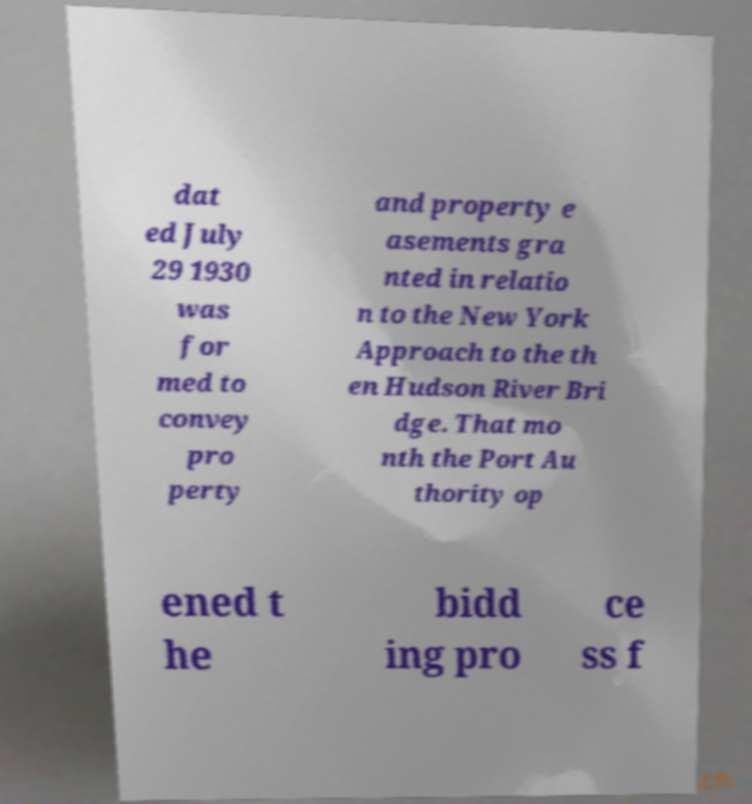For documentation purposes, I need the text within this image transcribed. Could you provide that? dat ed July 29 1930 was for med to convey pro perty and property e asements gra nted in relatio n to the New York Approach to the th en Hudson River Bri dge. That mo nth the Port Au thority op ened t he bidd ing pro ce ss f 